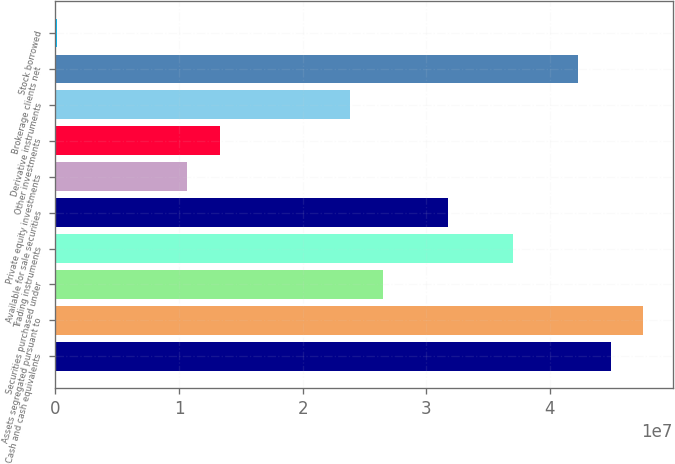<chart> <loc_0><loc_0><loc_500><loc_500><bar_chart><fcel>Cash and cash equivalents<fcel>Assets segregated pursuant to<fcel>Securities purchased under<fcel>Trading instruments<fcel>Available for sale securities<fcel>Private equity investments<fcel>Other investments<fcel>Derivative instruments<fcel>Brokerage clients net<fcel>Stock borrowed<nl><fcel>4.49086e+07<fcel>4.7543e+07<fcel>2.6468e+07<fcel>3.70055e+07<fcel>3.17368e+07<fcel>1.06618e+07<fcel>1.32962e+07<fcel>2.38337e+07<fcel>4.22742e+07<fcel>124373<nl></chart> 